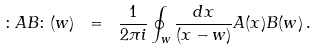<formula> <loc_0><loc_0><loc_500><loc_500>\colon A B \colon ( w ) \ = \ \frac { 1 } { 2 \pi i } \oint _ { w } \frac { d x } { ( x - w ) } A ( x ) B ( w ) \, .</formula> 